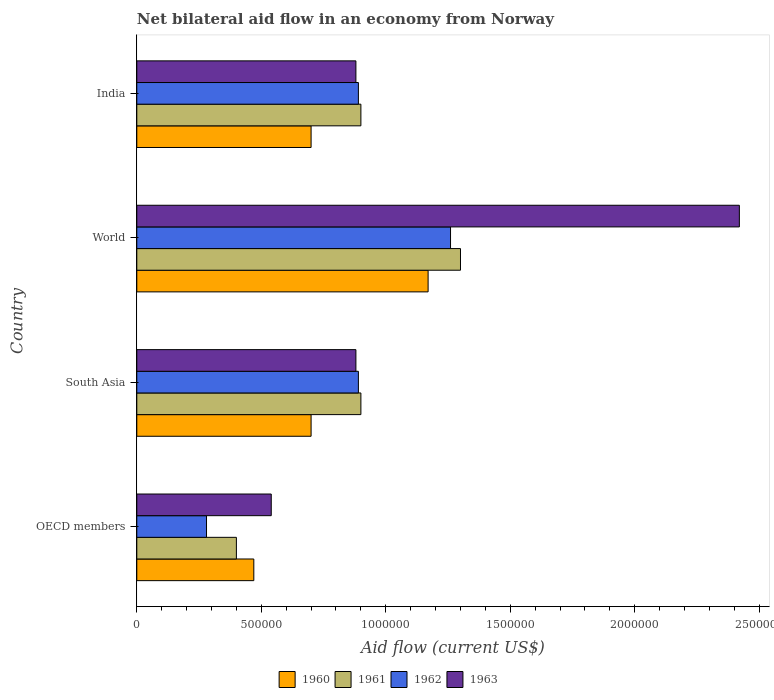How many different coloured bars are there?
Ensure brevity in your answer.  4. How many groups of bars are there?
Provide a succinct answer. 4. Are the number of bars on each tick of the Y-axis equal?
Your answer should be very brief. Yes. How many bars are there on the 3rd tick from the bottom?
Your response must be concise. 4. In how many cases, is the number of bars for a given country not equal to the number of legend labels?
Offer a terse response. 0. What is the net bilateral aid flow in 1963 in India?
Provide a short and direct response. 8.80e+05. Across all countries, what is the maximum net bilateral aid flow in 1962?
Your answer should be compact. 1.26e+06. In which country was the net bilateral aid flow in 1962 minimum?
Your response must be concise. OECD members. What is the total net bilateral aid flow in 1962 in the graph?
Provide a succinct answer. 3.32e+06. What is the difference between the net bilateral aid flow in 1960 in OECD members and that in World?
Your answer should be very brief. -7.00e+05. What is the average net bilateral aid flow in 1962 per country?
Your answer should be compact. 8.30e+05. In how many countries, is the net bilateral aid flow in 1960 greater than 2200000 US$?
Provide a succinct answer. 0. What is the ratio of the net bilateral aid flow in 1960 in India to that in South Asia?
Keep it short and to the point. 1. Is the net bilateral aid flow in 1961 in India less than that in World?
Provide a succinct answer. Yes. What is the difference between the highest and the second highest net bilateral aid flow in 1960?
Your answer should be compact. 4.70e+05. What is the difference between the highest and the lowest net bilateral aid flow in 1960?
Make the answer very short. 7.00e+05. Is the sum of the net bilateral aid flow in 1960 in India and World greater than the maximum net bilateral aid flow in 1962 across all countries?
Your answer should be compact. Yes. Is it the case that in every country, the sum of the net bilateral aid flow in 1962 and net bilateral aid flow in 1961 is greater than the sum of net bilateral aid flow in 1963 and net bilateral aid flow in 1960?
Your response must be concise. No. What does the 2nd bar from the top in OECD members represents?
Keep it short and to the point. 1962. What does the 2nd bar from the bottom in India represents?
Your answer should be compact. 1961. Are all the bars in the graph horizontal?
Your answer should be compact. Yes. Are the values on the major ticks of X-axis written in scientific E-notation?
Make the answer very short. No. Does the graph contain any zero values?
Provide a succinct answer. No. Does the graph contain grids?
Offer a very short reply. No. How many legend labels are there?
Ensure brevity in your answer.  4. What is the title of the graph?
Make the answer very short. Net bilateral aid flow in an economy from Norway. What is the Aid flow (current US$) of 1960 in OECD members?
Your response must be concise. 4.70e+05. What is the Aid flow (current US$) in 1961 in OECD members?
Keep it short and to the point. 4.00e+05. What is the Aid flow (current US$) in 1962 in OECD members?
Offer a very short reply. 2.80e+05. What is the Aid flow (current US$) of 1963 in OECD members?
Your answer should be compact. 5.40e+05. What is the Aid flow (current US$) in 1961 in South Asia?
Keep it short and to the point. 9.00e+05. What is the Aid flow (current US$) in 1962 in South Asia?
Offer a terse response. 8.90e+05. What is the Aid flow (current US$) of 1963 in South Asia?
Provide a short and direct response. 8.80e+05. What is the Aid flow (current US$) of 1960 in World?
Your answer should be very brief. 1.17e+06. What is the Aid flow (current US$) of 1961 in World?
Ensure brevity in your answer.  1.30e+06. What is the Aid flow (current US$) of 1962 in World?
Ensure brevity in your answer.  1.26e+06. What is the Aid flow (current US$) in 1963 in World?
Provide a succinct answer. 2.42e+06. What is the Aid flow (current US$) in 1962 in India?
Keep it short and to the point. 8.90e+05. What is the Aid flow (current US$) in 1963 in India?
Your answer should be very brief. 8.80e+05. Across all countries, what is the maximum Aid flow (current US$) of 1960?
Offer a terse response. 1.17e+06. Across all countries, what is the maximum Aid flow (current US$) in 1961?
Keep it short and to the point. 1.30e+06. Across all countries, what is the maximum Aid flow (current US$) in 1962?
Give a very brief answer. 1.26e+06. Across all countries, what is the maximum Aid flow (current US$) in 1963?
Provide a succinct answer. 2.42e+06. Across all countries, what is the minimum Aid flow (current US$) in 1960?
Your response must be concise. 4.70e+05. Across all countries, what is the minimum Aid flow (current US$) in 1961?
Your answer should be very brief. 4.00e+05. Across all countries, what is the minimum Aid flow (current US$) of 1962?
Your answer should be very brief. 2.80e+05. Across all countries, what is the minimum Aid flow (current US$) in 1963?
Ensure brevity in your answer.  5.40e+05. What is the total Aid flow (current US$) in 1960 in the graph?
Your answer should be very brief. 3.04e+06. What is the total Aid flow (current US$) of 1961 in the graph?
Make the answer very short. 3.50e+06. What is the total Aid flow (current US$) of 1962 in the graph?
Your response must be concise. 3.32e+06. What is the total Aid flow (current US$) of 1963 in the graph?
Your response must be concise. 4.72e+06. What is the difference between the Aid flow (current US$) of 1961 in OECD members and that in South Asia?
Make the answer very short. -5.00e+05. What is the difference between the Aid flow (current US$) of 1962 in OECD members and that in South Asia?
Ensure brevity in your answer.  -6.10e+05. What is the difference between the Aid flow (current US$) of 1963 in OECD members and that in South Asia?
Your answer should be very brief. -3.40e+05. What is the difference between the Aid flow (current US$) in 1960 in OECD members and that in World?
Your answer should be very brief. -7.00e+05. What is the difference between the Aid flow (current US$) of 1961 in OECD members and that in World?
Keep it short and to the point. -9.00e+05. What is the difference between the Aid flow (current US$) of 1962 in OECD members and that in World?
Your answer should be compact. -9.80e+05. What is the difference between the Aid flow (current US$) of 1963 in OECD members and that in World?
Your response must be concise. -1.88e+06. What is the difference between the Aid flow (current US$) of 1961 in OECD members and that in India?
Make the answer very short. -5.00e+05. What is the difference between the Aid flow (current US$) in 1962 in OECD members and that in India?
Offer a very short reply. -6.10e+05. What is the difference between the Aid flow (current US$) in 1960 in South Asia and that in World?
Your response must be concise. -4.70e+05. What is the difference between the Aid flow (current US$) of 1961 in South Asia and that in World?
Give a very brief answer. -4.00e+05. What is the difference between the Aid flow (current US$) in 1962 in South Asia and that in World?
Your answer should be compact. -3.70e+05. What is the difference between the Aid flow (current US$) of 1963 in South Asia and that in World?
Make the answer very short. -1.54e+06. What is the difference between the Aid flow (current US$) of 1960 in World and that in India?
Your answer should be very brief. 4.70e+05. What is the difference between the Aid flow (current US$) of 1961 in World and that in India?
Your answer should be very brief. 4.00e+05. What is the difference between the Aid flow (current US$) in 1963 in World and that in India?
Your answer should be compact. 1.54e+06. What is the difference between the Aid flow (current US$) in 1960 in OECD members and the Aid flow (current US$) in 1961 in South Asia?
Provide a succinct answer. -4.30e+05. What is the difference between the Aid flow (current US$) in 1960 in OECD members and the Aid flow (current US$) in 1962 in South Asia?
Offer a terse response. -4.20e+05. What is the difference between the Aid flow (current US$) of 1960 in OECD members and the Aid flow (current US$) of 1963 in South Asia?
Provide a succinct answer. -4.10e+05. What is the difference between the Aid flow (current US$) in 1961 in OECD members and the Aid flow (current US$) in 1962 in South Asia?
Your response must be concise. -4.90e+05. What is the difference between the Aid flow (current US$) in 1961 in OECD members and the Aid flow (current US$) in 1963 in South Asia?
Offer a terse response. -4.80e+05. What is the difference between the Aid flow (current US$) in 1962 in OECD members and the Aid flow (current US$) in 1963 in South Asia?
Keep it short and to the point. -6.00e+05. What is the difference between the Aid flow (current US$) of 1960 in OECD members and the Aid flow (current US$) of 1961 in World?
Offer a terse response. -8.30e+05. What is the difference between the Aid flow (current US$) of 1960 in OECD members and the Aid flow (current US$) of 1962 in World?
Offer a very short reply. -7.90e+05. What is the difference between the Aid flow (current US$) in 1960 in OECD members and the Aid flow (current US$) in 1963 in World?
Provide a succinct answer. -1.95e+06. What is the difference between the Aid flow (current US$) of 1961 in OECD members and the Aid flow (current US$) of 1962 in World?
Ensure brevity in your answer.  -8.60e+05. What is the difference between the Aid flow (current US$) of 1961 in OECD members and the Aid flow (current US$) of 1963 in World?
Make the answer very short. -2.02e+06. What is the difference between the Aid flow (current US$) in 1962 in OECD members and the Aid flow (current US$) in 1963 in World?
Keep it short and to the point. -2.14e+06. What is the difference between the Aid flow (current US$) of 1960 in OECD members and the Aid flow (current US$) of 1961 in India?
Make the answer very short. -4.30e+05. What is the difference between the Aid flow (current US$) of 1960 in OECD members and the Aid flow (current US$) of 1962 in India?
Provide a short and direct response. -4.20e+05. What is the difference between the Aid flow (current US$) in 1960 in OECD members and the Aid flow (current US$) in 1963 in India?
Keep it short and to the point. -4.10e+05. What is the difference between the Aid flow (current US$) in 1961 in OECD members and the Aid flow (current US$) in 1962 in India?
Keep it short and to the point. -4.90e+05. What is the difference between the Aid flow (current US$) of 1961 in OECD members and the Aid flow (current US$) of 1963 in India?
Your answer should be very brief. -4.80e+05. What is the difference between the Aid flow (current US$) of 1962 in OECD members and the Aid flow (current US$) of 1963 in India?
Give a very brief answer. -6.00e+05. What is the difference between the Aid flow (current US$) of 1960 in South Asia and the Aid flow (current US$) of 1961 in World?
Your answer should be very brief. -6.00e+05. What is the difference between the Aid flow (current US$) in 1960 in South Asia and the Aid flow (current US$) in 1962 in World?
Provide a short and direct response. -5.60e+05. What is the difference between the Aid flow (current US$) in 1960 in South Asia and the Aid flow (current US$) in 1963 in World?
Your answer should be compact. -1.72e+06. What is the difference between the Aid flow (current US$) of 1961 in South Asia and the Aid flow (current US$) of 1962 in World?
Provide a short and direct response. -3.60e+05. What is the difference between the Aid flow (current US$) of 1961 in South Asia and the Aid flow (current US$) of 1963 in World?
Ensure brevity in your answer.  -1.52e+06. What is the difference between the Aid flow (current US$) in 1962 in South Asia and the Aid flow (current US$) in 1963 in World?
Provide a short and direct response. -1.53e+06. What is the difference between the Aid flow (current US$) in 1960 in South Asia and the Aid flow (current US$) in 1961 in India?
Make the answer very short. -2.00e+05. What is the difference between the Aid flow (current US$) in 1960 in South Asia and the Aid flow (current US$) in 1962 in India?
Provide a short and direct response. -1.90e+05. What is the difference between the Aid flow (current US$) of 1960 in South Asia and the Aid flow (current US$) of 1963 in India?
Your answer should be very brief. -1.80e+05. What is the difference between the Aid flow (current US$) in 1961 in South Asia and the Aid flow (current US$) in 1962 in India?
Offer a very short reply. 10000. What is the difference between the Aid flow (current US$) in 1961 in South Asia and the Aid flow (current US$) in 1963 in India?
Give a very brief answer. 2.00e+04. What is the difference between the Aid flow (current US$) in 1962 in South Asia and the Aid flow (current US$) in 1963 in India?
Make the answer very short. 10000. What is the difference between the Aid flow (current US$) of 1960 in World and the Aid flow (current US$) of 1961 in India?
Make the answer very short. 2.70e+05. What is the difference between the Aid flow (current US$) in 1960 in World and the Aid flow (current US$) in 1962 in India?
Ensure brevity in your answer.  2.80e+05. What is the difference between the Aid flow (current US$) of 1962 in World and the Aid flow (current US$) of 1963 in India?
Your answer should be compact. 3.80e+05. What is the average Aid flow (current US$) in 1960 per country?
Your answer should be compact. 7.60e+05. What is the average Aid flow (current US$) in 1961 per country?
Your answer should be compact. 8.75e+05. What is the average Aid flow (current US$) in 1962 per country?
Offer a terse response. 8.30e+05. What is the average Aid flow (current US$) in 1963 per country?
Provide a succinct answer. 1.18e+06. What is the difference between the Aid flow (current US$) of 1961 and Aid flow (current US$) of 1962 in OECD members?
Provide a succinct answer. 1.20e+05. What is the difference between the Aid flow (current US$) in 1962 and Aid flow (current US$) in 1963 in OECD members?
Provide a succinct answer. -2.60e+05. What is the difference between the Aid flow (current US$) in 1960 and Aid flow (current US$) in 1962 in South Asia?
Give a very brief answer. -1.90e+05. What is the difference between the Aid flow (current US$) in 1961 and Aid flow (current US$) in 1962 in South Asia?
Make the answer very short. 10000. What is the difference between the Aid flow (current US$) in 1960 and Aid flow (current US$) in 1963 in World?
Give a very brief answer. -1.25e+06. What is the difference between the Aid flow (current US$) in 1961 and Aid flow (current US$) in 1962 in World?
Make the answer very short. 4.00e+04. What is the difference between the Aid flow (current US$) of 1961 and Aid flow (current US$) of 1963 in World?
Give a very brief answer. -1.12e+06. What is the difference between the Aid flow (current US$) in 1962 and Aid flow (current US$) in 1963 in World?
Ensure brevity in your answer.  -1.16e+06. What is the difference between the Aid flow (current US$) in 1960 and Aid flow (current US$) in 1961 in India?
Ensure brevity in your answer.  -2.00e+05. What is the difference between the Aid flow (current US$) in 1960 and Aid flow (current US$) in 1963 in India?
Offer a very short reply. -1.80e+05. What is the difference between the Aid flow (current US$) in 1961 and Aid flow (current US$) in 1962 in India?
Provide a succinct answer. 10000. What is the difference between the Aid flow (current US$) in 1962 and Aid flow (current US$) in 1963 in India?
Offer a terse response. 10000. What is the ratio of the Aid flow (current US$) in 1960 in OECD members to that in South Asia?
Your answer should be compact. 0.67. What is the ratio of the Aid flow (current US$) in 1961 in OECD members to that in South Asia?
Keep it short and to the point. 0.44. What is the ratio of the Aid flow (current US$) in 1962 in OECD members to that in South Asia?
Your response must be concise. 0.31. What is the ratio of the Aid flow (current US$) of 1963 in OECD members to that in South Asia?
Ensure brevity in your answer.  0.61. What is the ratio of the Aid flow (current US$) of 1960 in OECD members to that in World?
Make the answer very short. 0.4. What is the ratio of the Aid flow (current US$) in 1961 in OECD members to that in World?
Your answer should be compact. 0.31. What is the ratio of the Aid flow (current US$) of 1962 in OECD members to that in World?
Give a very brief answer. 0.22. What is the ratio of the Aid flow (current US$) in 1963 in OECD members to that in World?
Your answer should be very brief. 0.22. What is the ratio of the Aid flow (current US$) in 1960 in OECD members to that in India?
Your response must be concise. 0.67. What is the ratio of the Aid flow (current US$) of 1961 in OECD members to that in India?
Provide a short and direct response. 0.44. What is the ratio of the Aid flow (current US$) in 1962 in OECD members to that in India?
Offer a terse response. 0.31. What is the ratio of the Aid flow (current US$) of 1963 in OECD members to that in India?
Give a very brief answer. 0.61. What is the ratio of the Aid flow (current US$) of 1960 in South Asia to that in World?
Offer a very short reply. 0.6. What is the ratio of the Aid flow (current US$) in 1961 in South Asia to that in World?
Offer a very short reply. 0.69. What is the ratio of the Aid flow (current US$) of 1962 in South Asia to that in World?
Offer a terse response. 0.71. What is the ratio of the Aid flow (current US$) of 1963 in South Asia to that in World?
Provide a succinct answer. 0.36. What is the ratio of the Aid flow (current US$) of 1960 in South Asia to that in India?
Provide a succinct answer. 1. What is the ratio of the Aid flow (current US$) of 1962 in South Asia to that in India?
Your answer should be very brief. 1. What is the ratio of the Aid flow (current US$) of 1960 in World to that in India?
Give a very brief answer. 1.67. What is the ratio of the Aid flow (current US$) of 1961 in World to that in India?
Your answer should be compact. 1.44. What is the ratio of the Aid flow (current US$) in 1962 in World to that in India?
Give a very brief answer. 1.42. What is the ratio of the Aid flow (current US$) in 1963 in World to that in India?
Your answer should be very brief. 2.75. What is the difference between the highest and the second highest Aid flow (current US$) of 1960?
Offer a very short reply. 4.70e+05. What is the difference between the highest and the second highest Aid flow (current US$) of 1961?
Provide a short and direct response. 4.00e+05. What is the difference between the highest and the second highest Aid flow (current US$) of 1963?
Keep it short and to the point. 1.54e+06. What is the difference between the highest and the lowest Aid flow (current US$) of 1961?
Your response must be concise. 9.00e+05. What is the difference between the highest and the lowest Aid flow (current US$) of 1962?
Provide a succinct answer. 9.80e+05. What is the difference between the highest and the lowest Aid flow (current US$) in 1963?
Provide a short and direct response. 1.88e+06. 